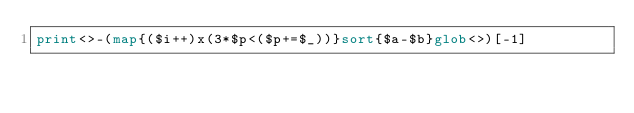<code> <loc_0><loc_0><loc_500><loc_500><_Perl_>print<>-(map{($i++)x(3*$p<($p+=$_))}sort{$a-$b}glob<>)[-1]</code> 